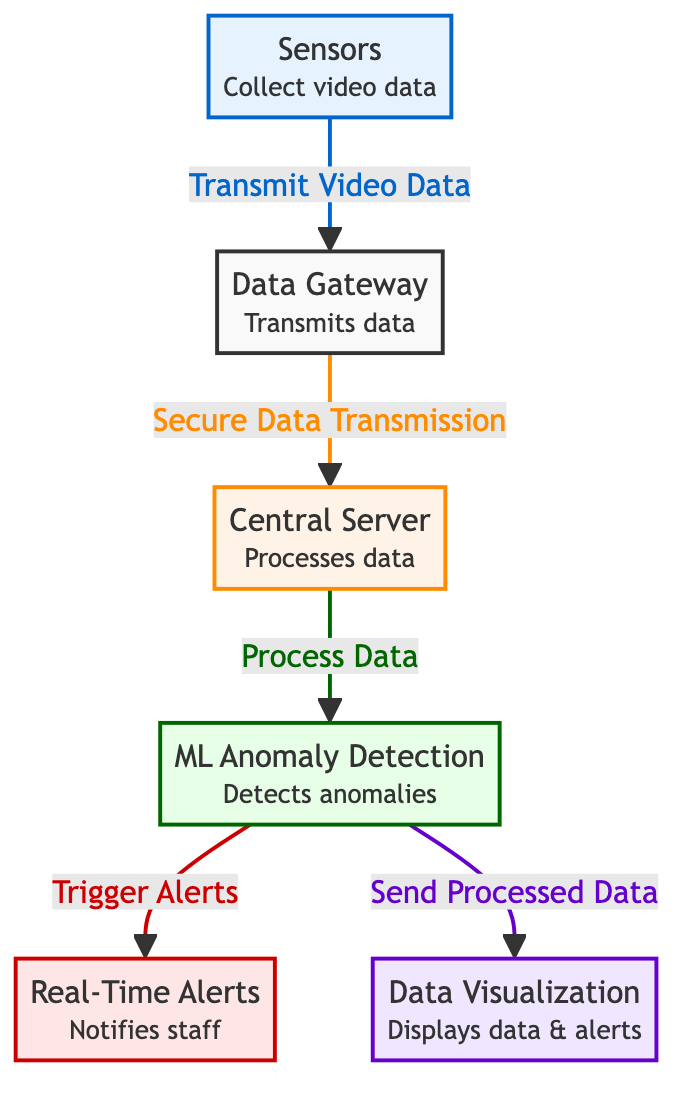What's the first component in the flow of the diagram? The first component is the "Sensors" which collect video data. Therefore, by examining the flowchart, I see that "Sensors" is at the starting point.
Answer: Sensors How many main components are shown in the diagram? The diagram outlines five main components including Sensors, Data Gateway, Central Server, ML Anomaly Detection, and Real-Time Alerts. Thus, by counting the nodes, there are five.
Answer: Five What does the Central Server do? The Central Server's function is to process the data that it receives, as indicated by the label on the component in the diagram. It does not perform any other functions in the flow.
Answer: Processes data Which component is responsible for sending alerts? The component responsible for sending alerts is the "Real-Time Alerts," as it directly receives triggers from the ML Anomaly Detection component. This is clear from the flow indicated in the diagram.
Answer: Real-Time Alerts How does the data flow from the Sensors to the Central Server? The data flows from the Sensors to the Data Gateway first, which secures the transmission before sending it to the Central Server for processing, as per the directional arrows in the diagram.
Answer: Data Gateway What kind of detection is performed by the ML component? The ML component performs "Anomaly Detection," as stated in its label, indicating its specific function within the system.
Answer: Anomaly Detection What does the data visualization component display? The Data Visualization component displays both processed data and alerts, as described in the small print under the component name in the diagram.
Answer: Displays data & alerts What triggers the alerts to be sent to the staff? Alerts are triggered by the ML Anomaly Detection when it detects anomalies in the processed data, establishing a clear cause-and-effect relationship noted in the diagram's flow.
Answer: ML Anomaly Detection Which component handles secure data transmission? The "Data Gateway" handles secure data transmission, acting as the intermediary between Sensors and the Central Server according to the connections illustrated in the diagram.
Answer: Data Gateway 